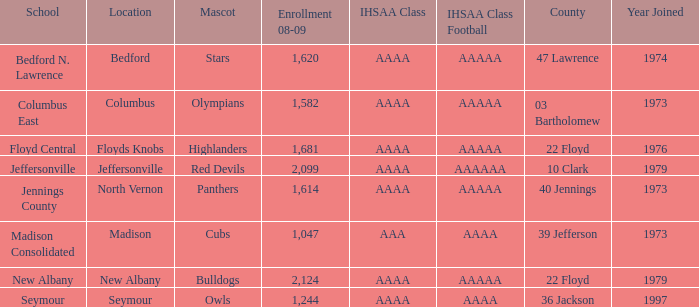If panthers are the mascot, which ihsaa class football does it represent? AAAAA. 